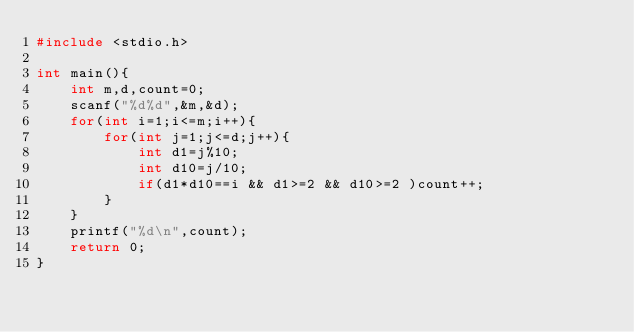Convert code to text. <code><loc_0><loc_0><loc_500><loc_500><_C_>#include <stdio.h>

int main(){
	int m,d,count=0;
	scanf("%d%d",&m,&d);
	for(int i=1;i<=m;i++){
		for(int j=1;j<=d;j++){
			int d1=j%10;
			int d10=j/10;
			if(d1*d10==i && d1>=2 && d10>=2 )count++;
		}
	}
	printf("%d\n",count);
	return 0;
}</code> 